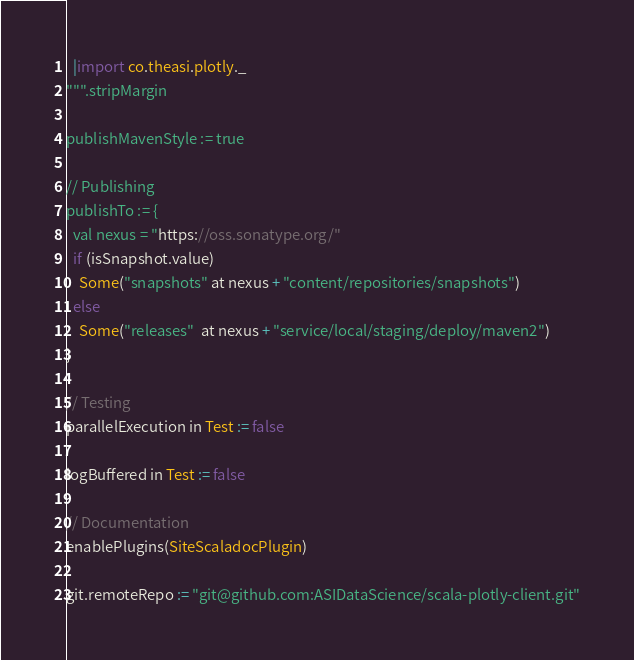Convert code to text. <code><loc_0><loc_0><loc_500><loc_500><_Scala_>  |import co.theasi.plotly._
""".stripMargin

publishMavenStyle := true

// Publishing
publishTo := {
  val nexus = "https://oss.sonatype.org/"
  if (isSnapshot.value)
    Some("snapshots" at nexus + "content/repositories/snapshots")
  else
    Some("releases"  at nexus + "service/local/staging/deploy/maven2")
}

// Testing
parallelExecution in Test := false

logBuffered in Test := false

// Documentation
enablePlugins(SiteScaladocPlugin)

git.remoteRepo := "git@github.com:ASIDataScience/scala-plotly-client.git"
</code> 